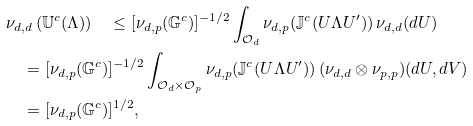<formula> <loc_0><loc_0><loc_500><loc_500>& \nu _ { d , d } \left ( \mathbb { U } ^ { c } ( \Lambda ) \right ) \quad \leq [ \nu _ { d , p } ( \mathbb { G } ^ { c } ) ] ^ { - 1 / 2 } \int _ { \mathcal { O } _ { d } } \nu _ { d , p } ( \mathbb { J } ^ { c } ( U \Lambda U ^ { \prime } ) ) \, \nu _ { d , d } ( d U ) \\ & \quad = [ \nu _ { d , p } ( \mathbb { G } ^ { c } ) ] ^ { - 1 / 2 } \int _ { \mathcal { O } _ { d } \times \mathcal { O } _ { p } } \nu _ { d , p } ( \mathbb { J } ^ { c } ( U \Lambda U ^ { \prime } ) ) \, ( \nu _ { d , d } \otimes \nu _ { p , p } ) ( d U , d V ) \\ & \quad = [ \nu _ { d , p } ( \mathbb { G } ^ { c } ) ] ^ { 1 / 2 } ,</formula> 